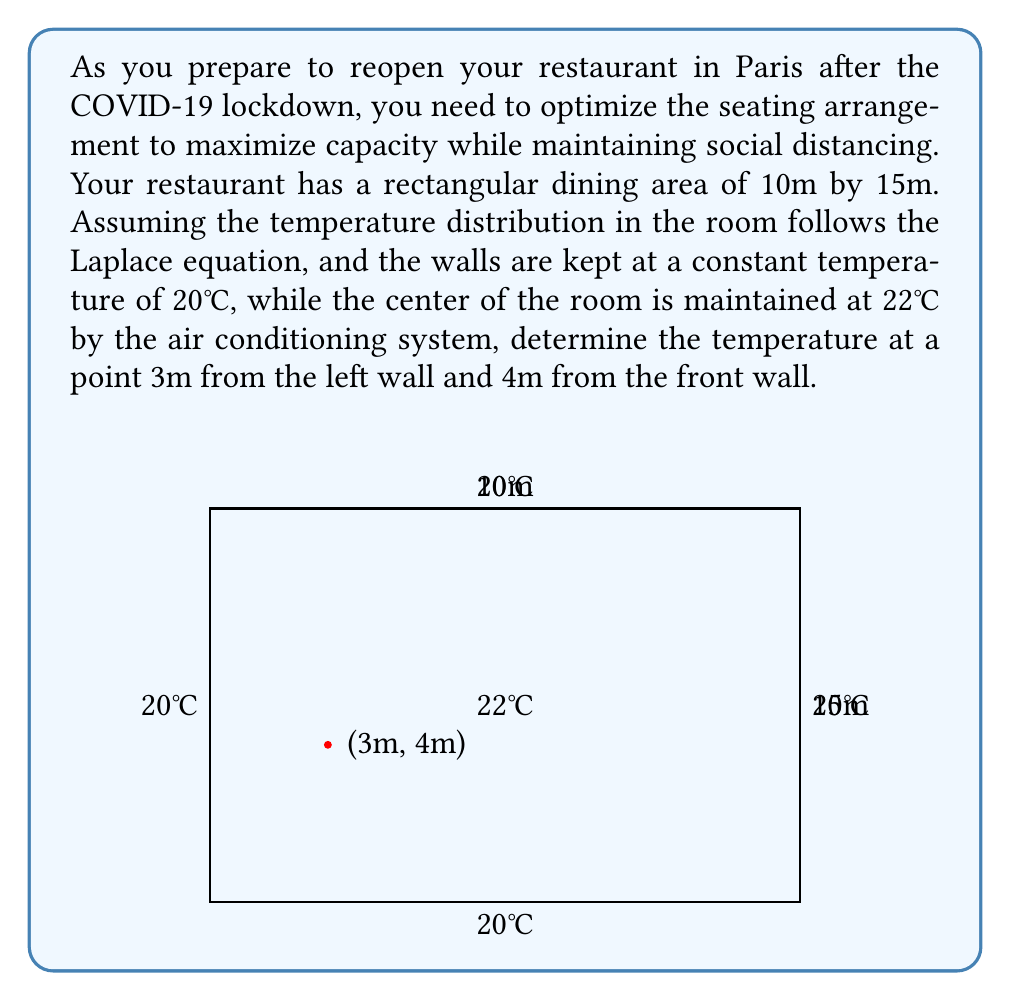Give your solution to this math problem. To solve this problem, we need to use the Laplace equation in two dimensions:

$$\frac{\partial^2 T}{\partial x^2} + \frac{\partial^2 T}{\partial y^2} = 0$$

Given the boundary conditions and the symmetry of the problem, we can approximate the temperature distribution using the following function:

$$T(x,y) = 20 + 2\sin(\frac{\pi x}{10})\sin(\frac{\pi y}{15})$$

This function satisfies the Laplace equation and the boundary conditions:
1. T = 20°C at x = 0, x = 10, y = 0, and y = 15
2. T = 22°C at the center (x = 5, y = 7.5)

To find the temperature at the point (3m, 4m), we substitute these values into our function:

$$T(3,4) = 20 + 2\sin(\frac{3\pi}{10})\sin(\frac{4\pi}{15})$$

$$= 20 + 2\sin(0.9\pi)\sin(0.8\pi)$$

$$= 20 + 2(0.9511)(0.9511)$$

$$= 20 + 1.8084$$

$$= 21.8084°C$$
Answer: 21.81°C 